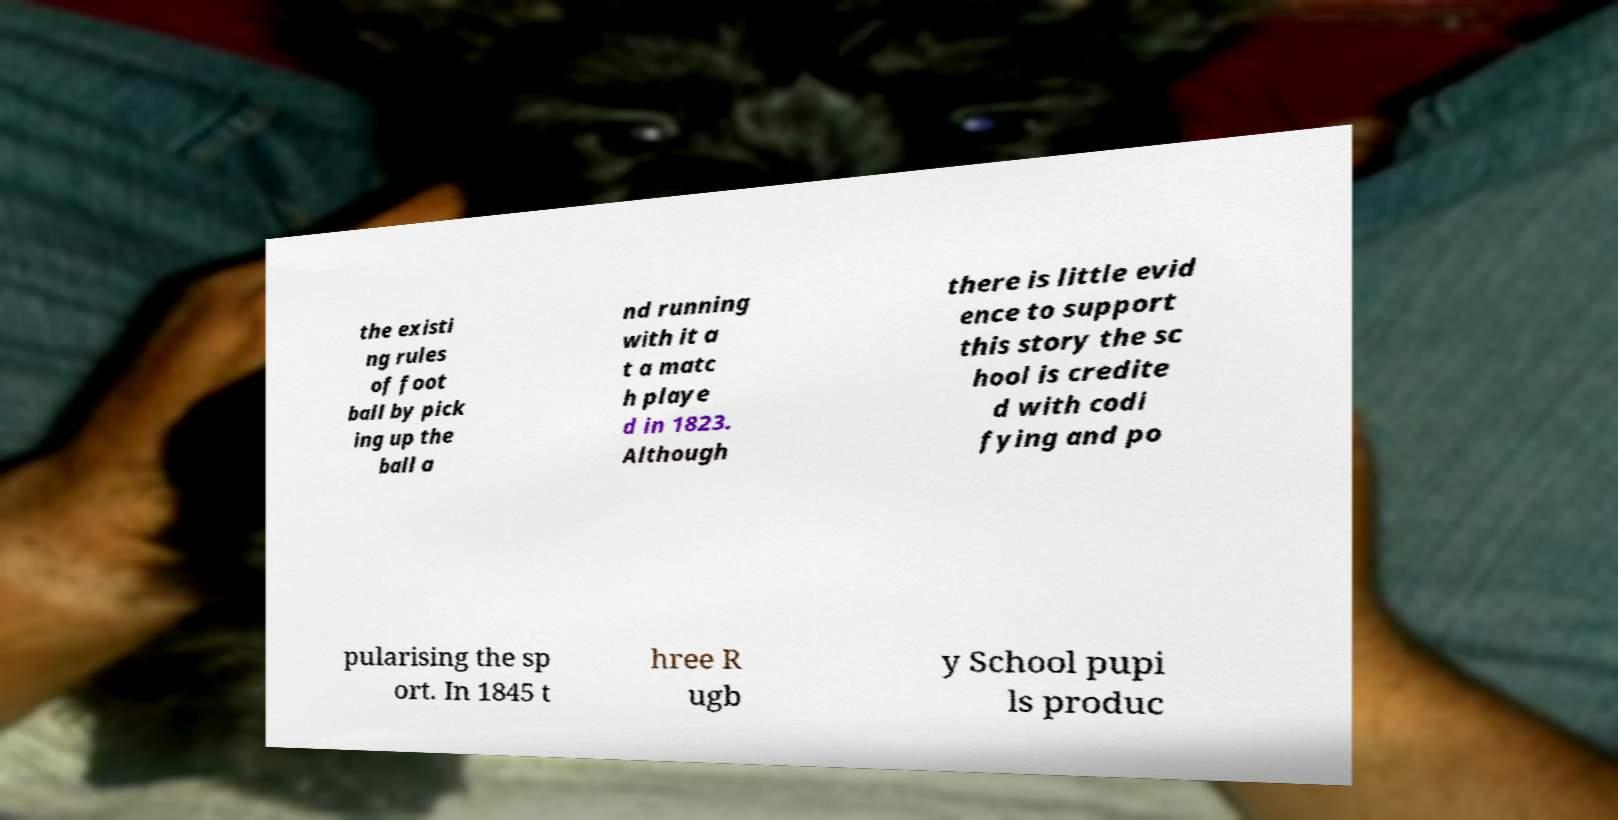Can you accurately transcribe the text from the provided image for me? the existi ng rules of foot ball by pick ing up the ball a nd running with it a t a matc h playe d in 1823. Although there is little evid ence to support this story the sc hool is credite d with codi fying and po pularising the sp ort. In 1845 t hree R ugb y School pupi ls produc 